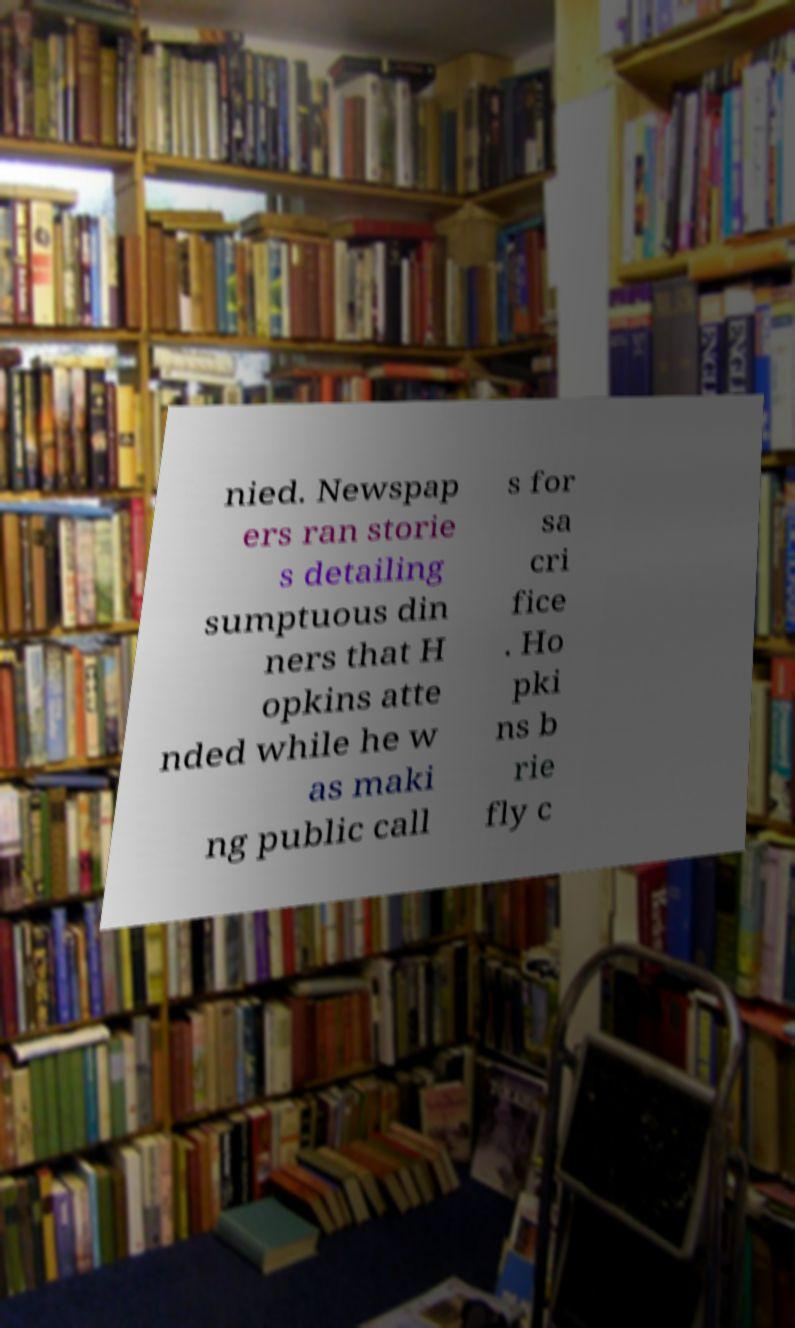Could you assist in decoding the text presented in this image and type it out clearly? nied. Newspap ers ran storie s detailing sumptuous din ners that H opkins atte nded while he w as maki ng public call s for sa cri fice . Ho pki ns b rie fly c 